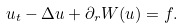Convert formula to latex. <formula><loc_0><loc_0><loc_500><loc_500>u _ { t } - \Delta u + \partial _ { r } W ( u ) = f .</formula> 